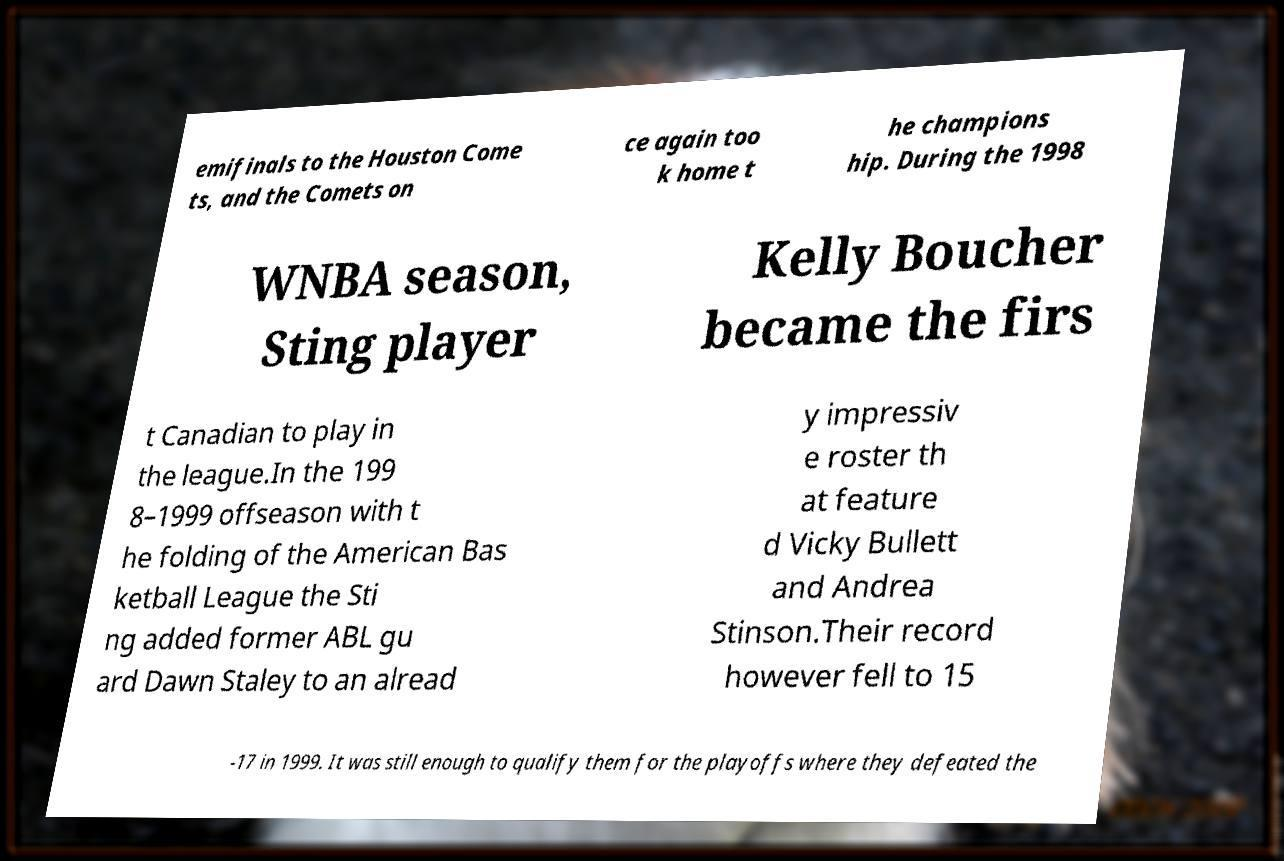There's text embedded in this image that I need extracted. Can you transcribe it verbatim? emifinals to the Houston Come ts, and the Comets on ce again too k home t he champions hip. During the 1998 WNBA season, Sting player Kelly Boucher became the firs t Canadian to play in the league.In the 199 8–1999 offseason with t he folding of the American Bas ketball League the Sti ng added former ABL gu ard Dawn Staley to an alread y impressiv e roster th at feature d Vicky Bullett and Andrea Stinson.Their record however fell to 15 -17 in 1999. It was still enough to qualify them for the playoffs where they defeated the 